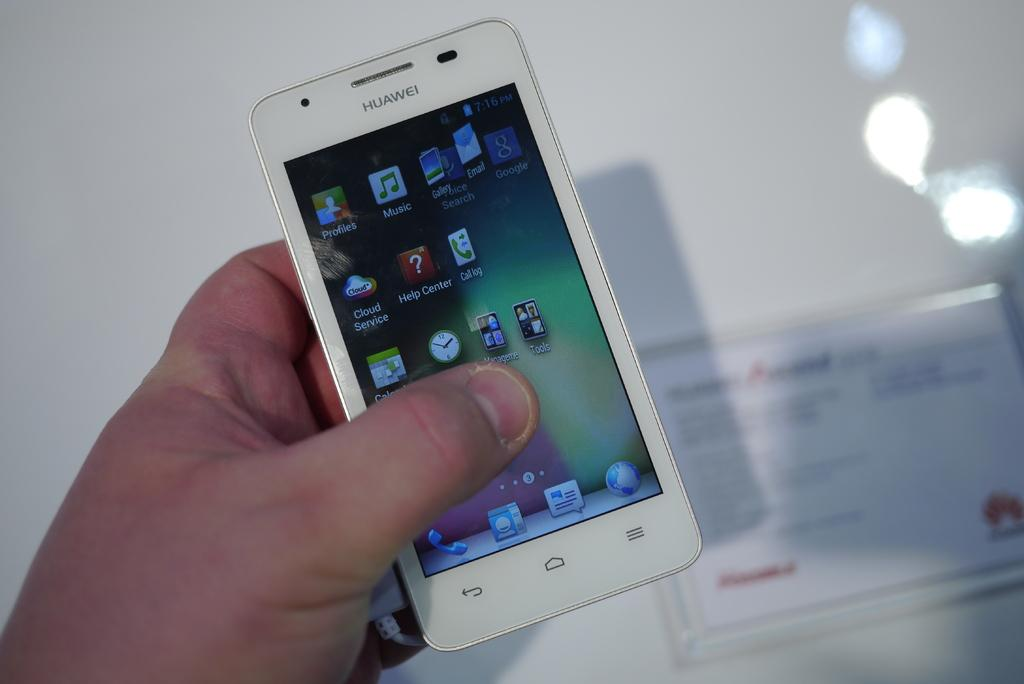What is located in the foreground of the image? There is a hand and a mobile in the foreground of the image. What can be seen on the wall in the background of the image? There is a frame on the wall in the background of the image. How does the hand account for the attack in the image? There is no attack or any indication of an attack in the image. The hand is simply holding a mobile in the foreground. 